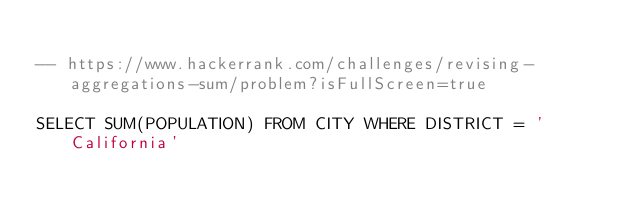Convert code to text. <code><loc_0><loc_0><loc_500><loc_500><_SQL_>
-- https://www.hackerrank.com/challenges/revising-aggregations-sum/problem?isFullScreen=true

SELECT SUM(POPULATION) FROM CITY WHERE DISTRICT = 'California'
</code> 